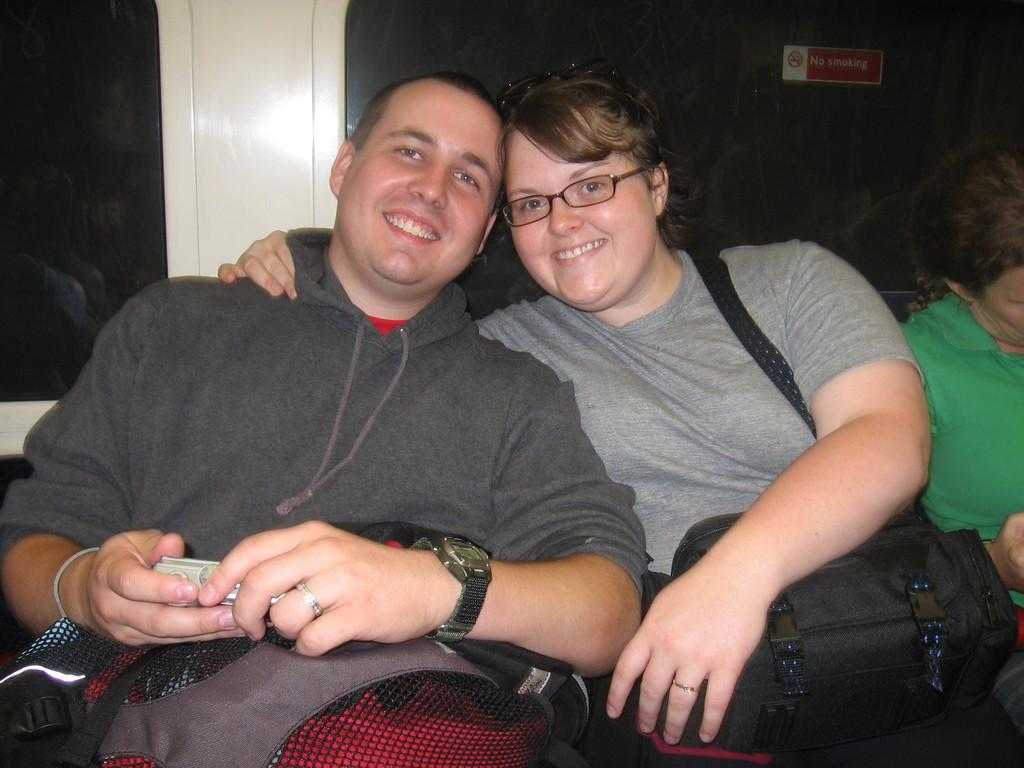What is happening in the image? There is a couple sitting in the image. What else can be seen in the image besides the couple? There are bags in the image. How many mice are crawling on the couple in the image? There are no mice present in the image; it only features a couple sitting and bags. 